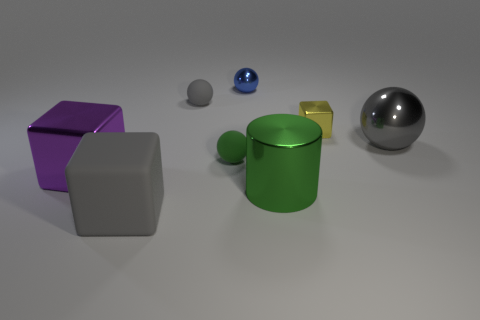Subtract all metallic blocks. How many blocks are left? 1 Subtract all brown blocks. How many gray balls are left? 2 Subtract all green balls. How many balls are left? 3 Add 1 rubber cylinders. How many objects exist? 9 Subtract all cyan balls. Subtract all gray cylinders. How many balls are left? 4 Subtract all cylinders. How many objects are left? 7 Subtract all brown objects. Subtract all big purple shiny objects. How many objects are left? 7 Add 6 tiny spheres. How many tiny spheres are left? 9 Add 6 small gray shiny balls. How many small gray shiny balls exist? 6 Subtract 0 cyan cylinders. How many objects are left? 8 